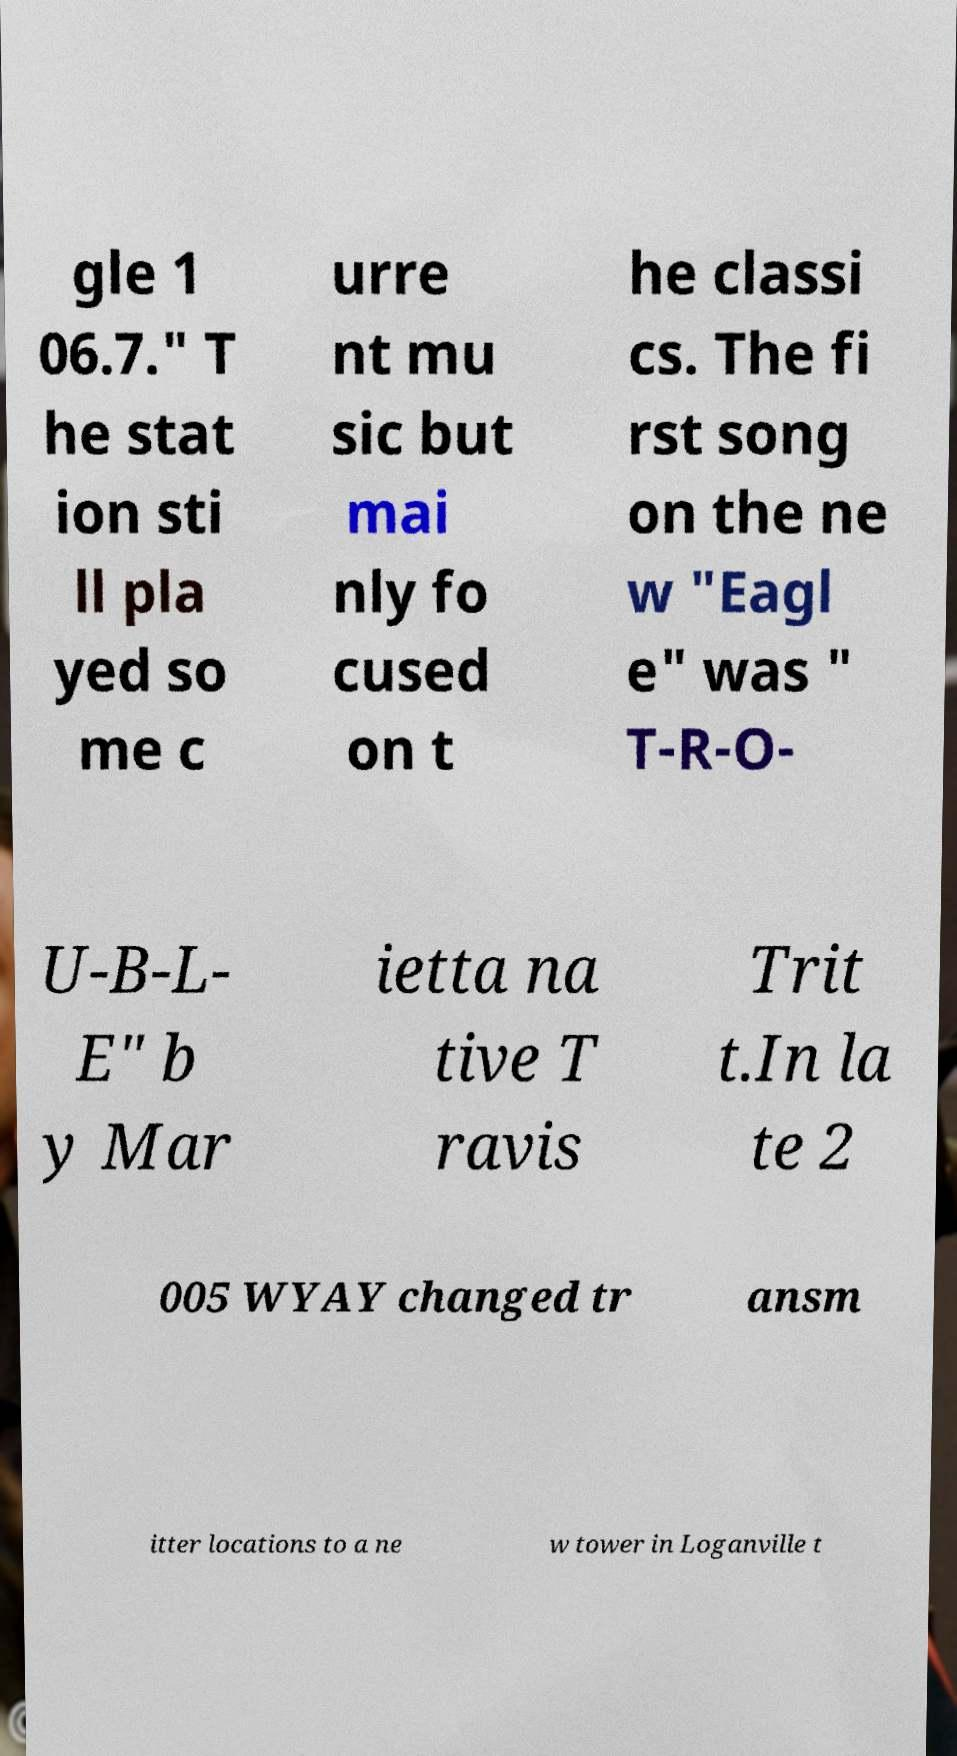Could you assist in decoding the text presented in this image and type it out clearly? gle 1 06.7." T he stat ion sti ll pla yed so me c urre nt mu sic but mai nly fo cused on t he classi cs. The fi rst song on the ne w "Eagl e" was " T-R-O- U-B-L- E" b y Mar ietta na tive T ravis Trit t.In la te 2 005 WYAY changed tr ansm itter locations to a ne w tower in Loganville t 